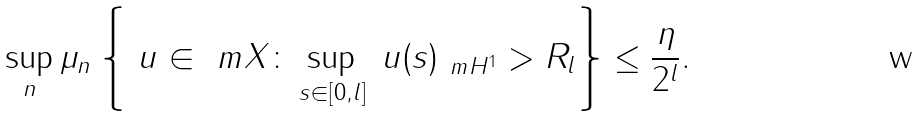Convert formula to latex. <formula><loc_0><loc_0><loc_500><loc_500>\sup _ { n } \mu _ { n } \left \{ \ u \in \ m X \colon \sup _ { s \in [ 0 , l ] } \| \ u ( s ) \| _ { \ m H ^ { 1 } } > R _ { l } \right \} \leq \frac { \eta } { 2 ^ { l } } .</formula> 